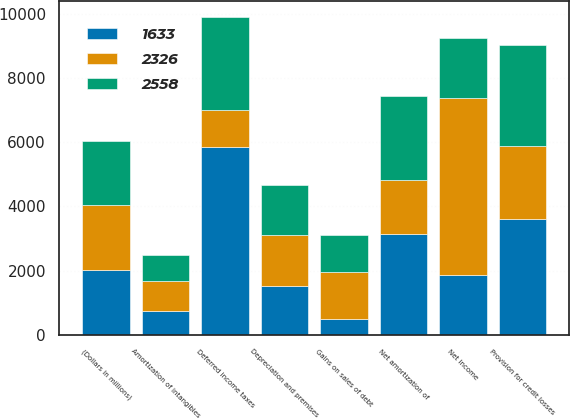Convert chart to OTSL. <chart><loc_0><loc_0><loc_500><loc_500><stacked_bar_chart><ecel><fcel>(Dollars in millions)<fcel>Net income<fcel>Provision for credit losses<fcel>Gains on sales of debt<fcel>Depreciation and premises<fcel>Amortization of intangibles<fcel>Net amortization of<fcel>Deferred income taxes<nl><fcel>1633<fcel>2016<fcel>1856.5<fcel>3597<fcel>490<fcel>1511<fcel>730<fcel>3134<fcel>5841<nl><fcel>2558<fcel>2015<fcel>1856.5<fcel>3161<fcel>1138<fcel>1555<fcel>834<fcel>2613<fcel>2924<nl><fcel>2326<fcel>2014<fcel>5520<fcel>2275<fcel>1481<fcel>1586<fcel>936<fcel>1699<fcel>1147<nl></chart> 